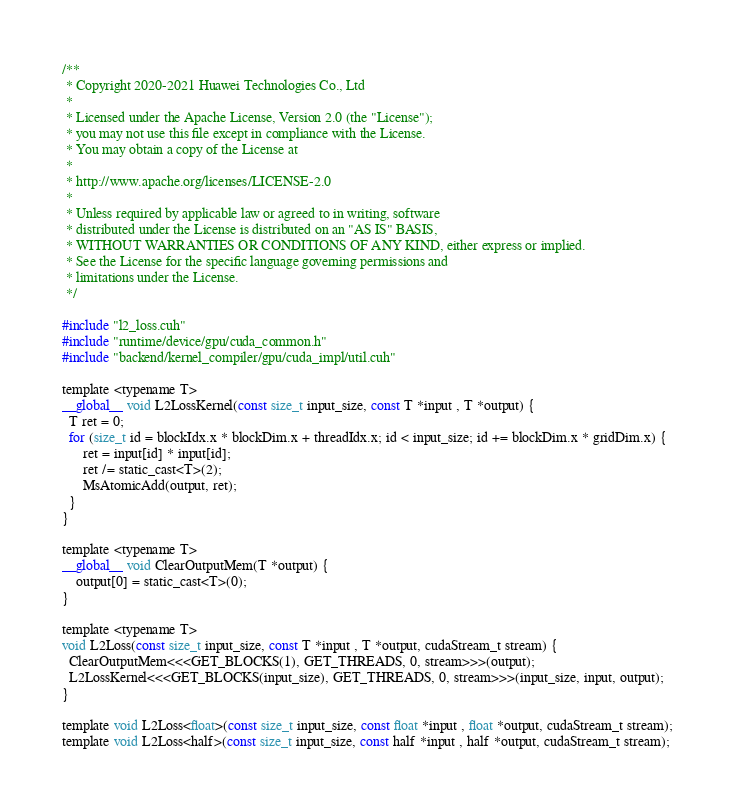<code> <loc_0><loc_0><loc_500><loc_500><_Cuda_>/**
 * Copyright 2020-2021 Huawei Technologies Co., Ltd
 *
 * Licensed under the Apache License, Version 2.0 (the "License");
 * you may not use this file except in compliance with the License.
 * You may obtain a copy of the License at
 *
 * http://www.apache.org/licenses/LICENSE-2.0
 *
 * Unless required by applicable law or agreed to in writing, software
 * distributed under the License is distributed on an "AS IS" BASIS,
 * WITHOUT WARRANTIES OR CONDITIONS OF ANY KIND, either express or implied.
 * See the License for the specific language governing permissions and
 * limitations under the License.
 */

#include "l2_loss.cuh"
#include "runtime/device/gpu/cuda_common.h"
#include "backend/kernel_compiler/gpu/cuda_impl/util.cuh"

template <typename T>
__global__ void L2LossKernel(const size_t input_size, const T *input , T *output) {
  T ret = 0;
  for (size_t id = blockIdx.x * blockDim.x + threadIdx.x; id < input_size; id += blockDim.x * gridDim.x) {
      ret = input[id] * input[id];
      ret /= static_cast<T>(2);
      MsAtomicAdd(output, ret);
  }
}

template <typename T>
__global__ void ClearOutputMem(T *output) {
    output[0] = static_cast<T>(0);
}

template <typename T>
void L2Loss(const size_t input_size, const T *input , T *output, cudaStream_t stream) {
  ClearOutputMem<<<GET_BLOCKS(1), GET_THREADS, 0, stream>>>(output);
  L2LossKernel<<<GET_BLOCKS(input_size), GET_THREADS, 0, stream>>>(input_size, input, output);
}

template void L2Loss<float>(const size_t input_size, const float *input , float *output, cudaStream_t stream);
template void L2Loss<half>(const size_t input_size, const half *input , half *output, cudaStream_t stream);
</code> 